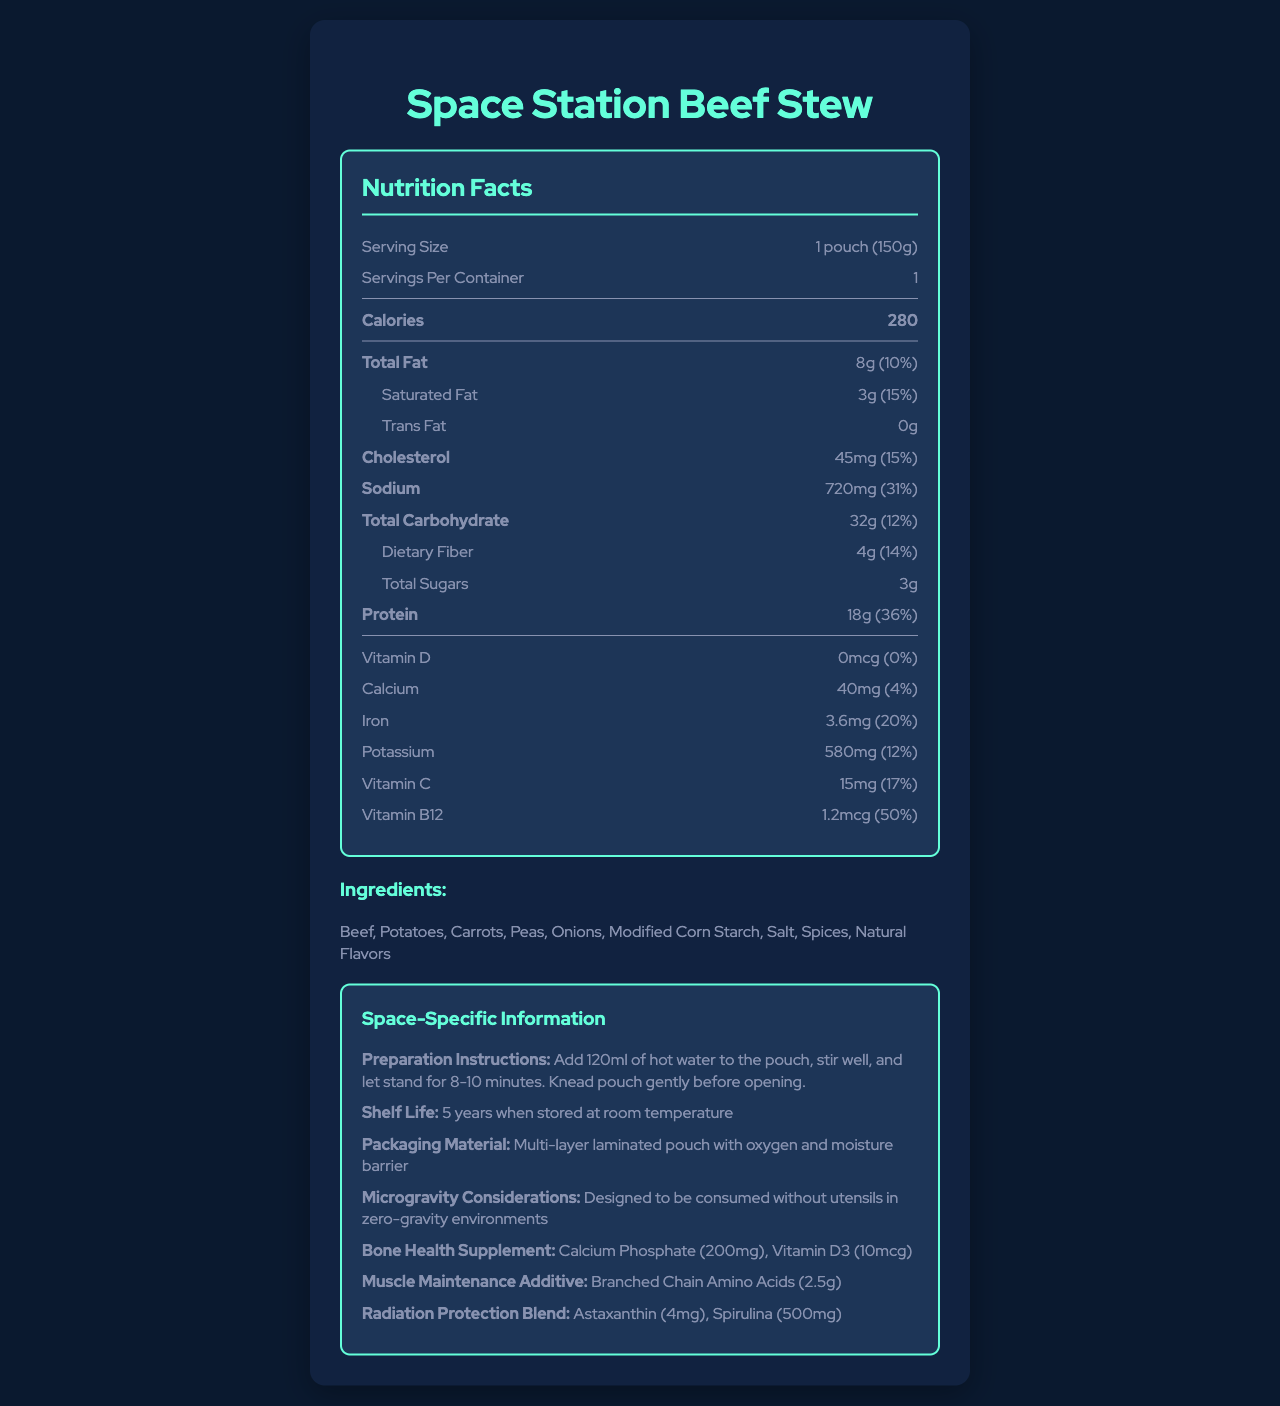what is the serving size for the Space Station Beef Stew? The serving size is listed at the top of the nutrition facts section as "1 pouch (150g)".
Answer: 1 pouch (150g) how many calories are in one serving? The calories per serving is clearly labeled in the bold section of the nutrition facts.
Answer: 280 what is the total fat content in the Space Station Beef Stew? The total fat content is listed as "8g" with a daily value percentage of 10%.
Answer: 8g (10%) which three ingredients are listed first in the ingredients section? The ingredients are listed in order starting with beef, followed by potatoes and carrots.
Answer: Beef, Potatoes, Carrots what is the daily value percentage of iron per serving? The daily value percentage for iron is shown as "20%" in the nutrition facts section.
Answer: 20% what is the shelf life of the Space Station Beef Stew? The shelf life is mentioned under the space-specific information section.
Answer: 5 years when stored at room temperature what additives are included for muscle maintenance? The muscle maintenance additive includes branched chain amino acids listed under the space-specific information section.
Answer: Branched Chain Amino Acids (2.5g) How much sodium is there in one serving of the product? The sodium content is listed as "720mg" with a daily value percentage of 31%.
Answer: 720mg (31%) what is the purpose of the bone health supplement listed? The bone health supplement section mentions Calcium Phosphate (200mg) and Vitamin D3 (10mcg) for bone health.
Answer: To enhance bone health in astronauts by providing calcium phosphate and Vitamin D3 what is the packaging material of this freeze-dried space food? The packaging material is listed in the space-specific information section.
Answer: Multi-layer laminated pouch with oxygen and moisture barrier what is the recommended method for preparing the beef stew? The preparation instructions are detailed in the space-specific information section.
Answer: Add 120ml of hot water to the pouch, stir well, and let it stand for 8-10 minutes. Knead pouch gently before opening. what total carbohydrate content is in one pouch of Space Station Beef Stew? The total carbohydrate content is mentioned as "32g" with a daily value percentage of 12%.
Answer: 32g (12%) which vitamin has the highest daily value percentage in the product? Under the nutrition facts, Vitamin B12 has a daily value percentage of 50%, the highest among the listed vitamins and minerals.
Answer: Vitamin B12 (50%) what does the space-specific section suggest about consuming this food in zero-gravity? A. Use utensils B. Consume without utensils C. Use a straw The microgravity considerations state that the product is designed to be consumed without utensils in zero-gravity environments.
Answer: B how is the nutritional profile of the Space Station Beef Stew optimized? A. For short-duration missions B. For taste preference C. For long-duration space missions One of the notes for engineers mentions that the nutritional profile is optimized for long-duration space missions.
Answer: C does the product contain any trans fat? The nutrition facts list the trans fat content as "0g".
Answer: No summarize the main idea of the document. The document is essentially a comprehensive nutrition label tailored for a space food product, highlighting its suitability for consumption in microgravity environments and optimized nutritional profile for space missions.
Answer: The document provides a detailed breakdown of the nutritional content, ingredients, preparation instructions, and special considerations for a freeze-dried space food product designed for astronauts, called Space Station Beef Stew. It offers numerous health benefits including bone health supplements, muscle maintenance additives, and radiation protection blends. what is the environmental impact of the packaging used for Space Station Beef Stew? The document does not provide any information regarding the environmental impact of the packaging material used.
Answer: Not enough information 